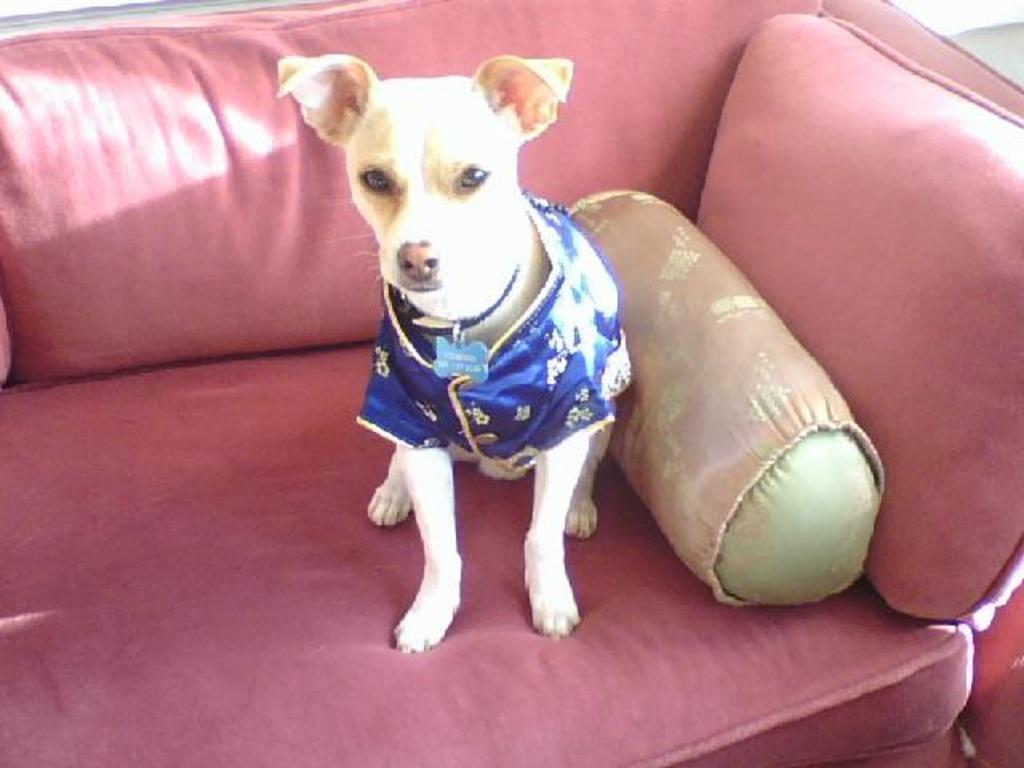What type of animal is in the image? There is a dog in the image. Where is the dog located? The dog is sitting on a sofa. What can be found on the sofa besides the dog? There are cushions placed on the sofa. How many pies are on the dog's stomach in the image? There are no pies present in the image, and the dog's stomach is not visible. 